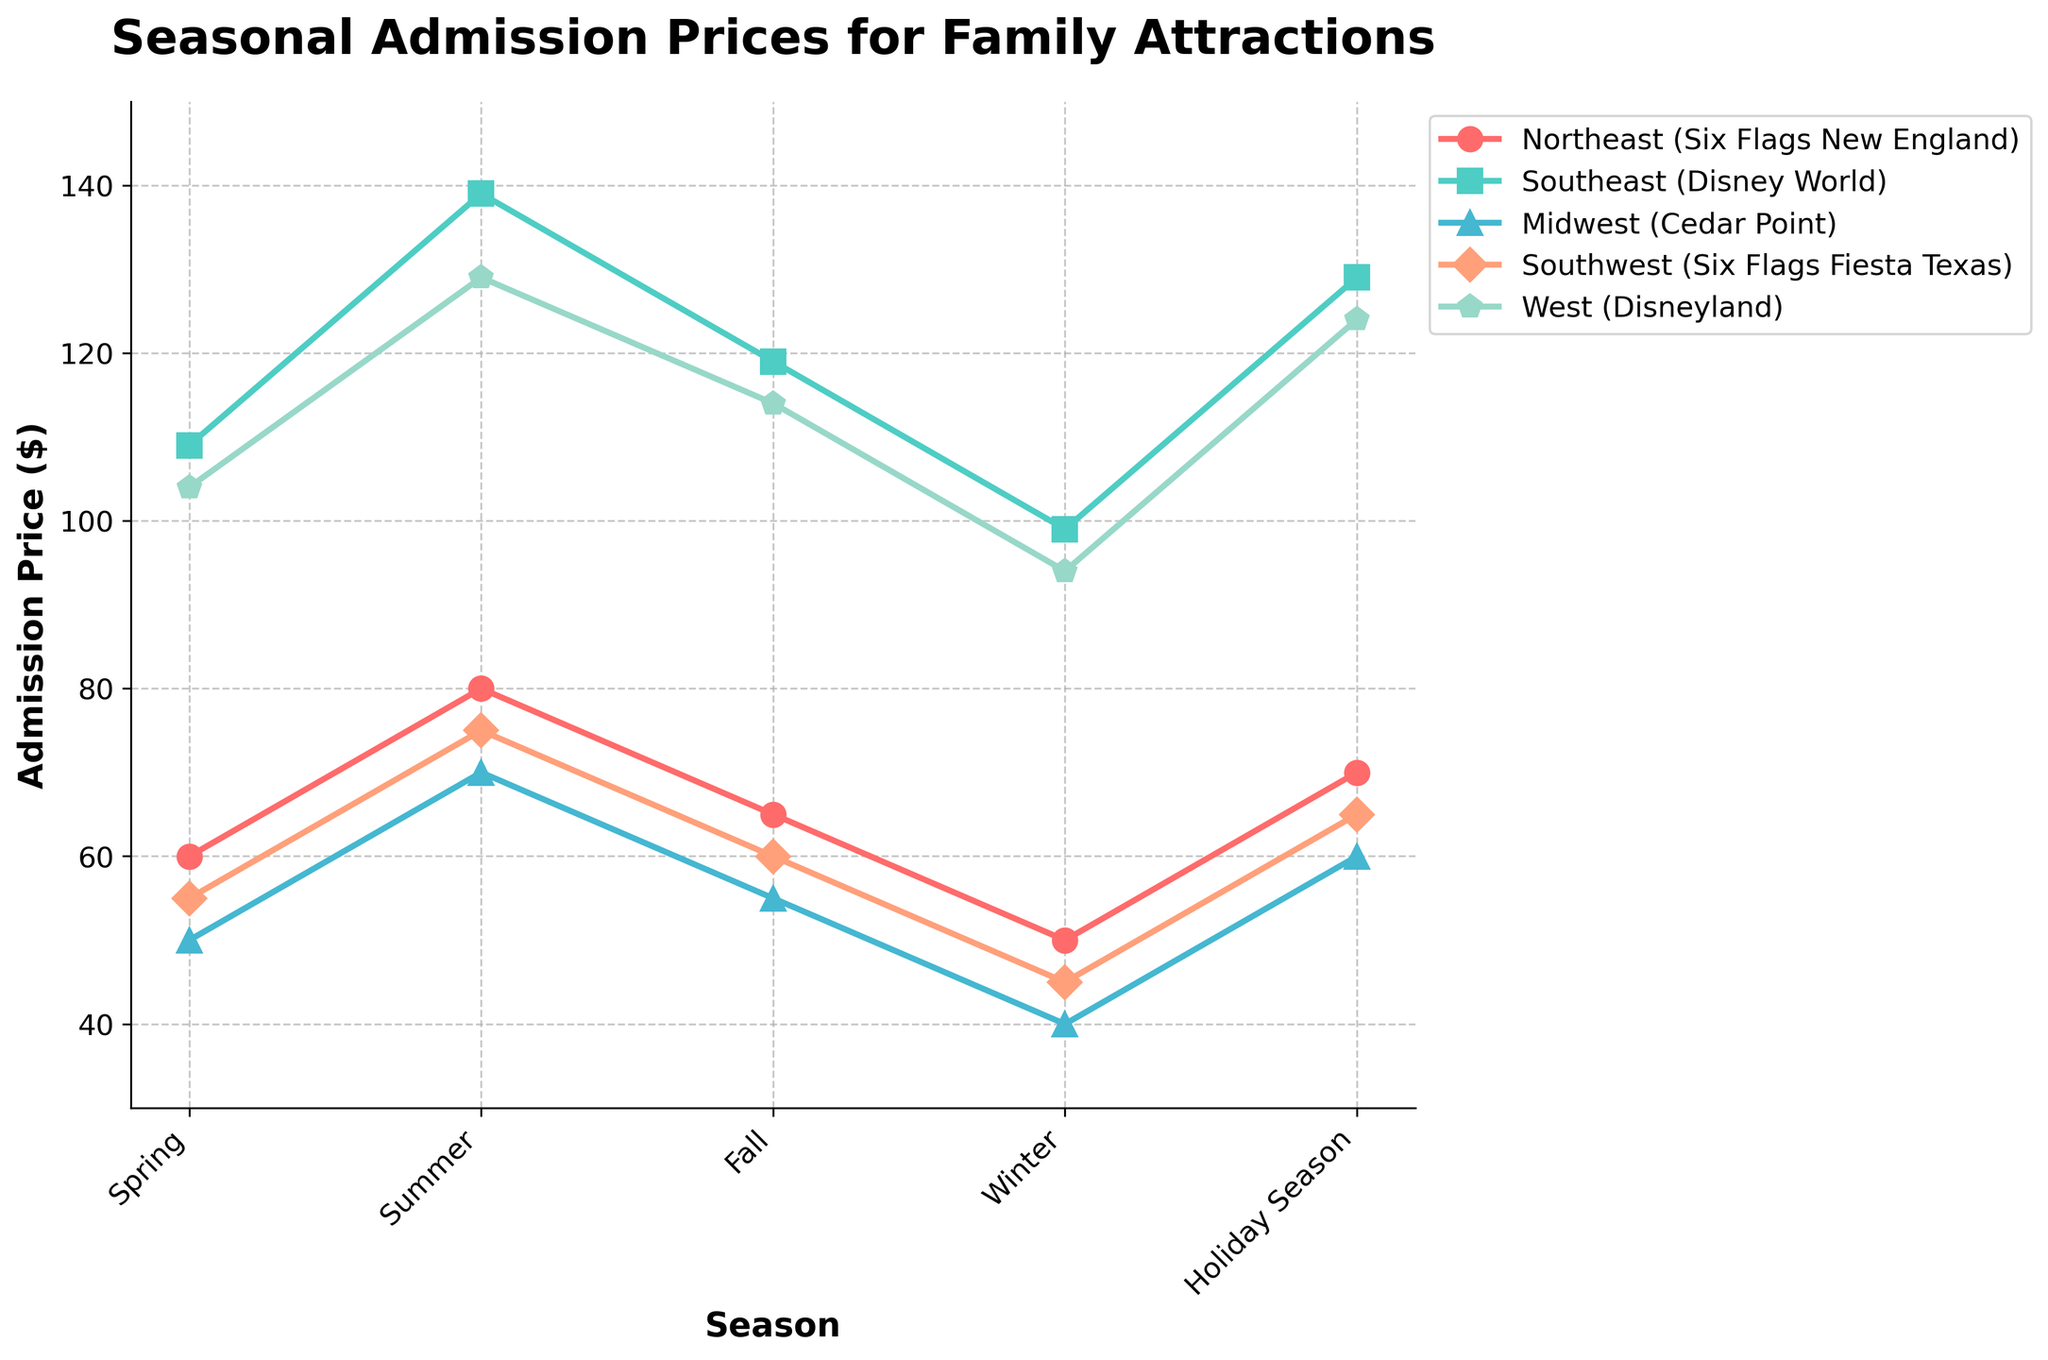what is the total admission price for Disneyland in each season? To find the total admission price for Disneyland across the five seasons, add the prices together: 104.00 (Spring) + 129.00 (Summer) + 114.00 (Fall) + 94.00 (Winter) + 124.00 (Holiday Season). This gives us a total of 565.00.
Answer: 565.00 Which attraction has the highest admission price in the summer? To determine the attraction with the highest admission price in the summer, compare the values for each attraction in the summer season: Six Flags New England (79.99), Disney World (139.00), Cedar Point (69.99), Six Flags Fiesta Texas (74.99), and Disneyland (129.00). Disney World has the highest admission price.
Answer: Disney World Which season shows the lowest admission price for Six Flags Fiesta Texas? To find the season with the lowest admission price for Six Flags Fiesta Texas, compare the prices across the seasons: Spring (54.99), Summer (74.99), Fall (59.99), Winter (44.99), and Holiday Season (64.99). The lowest price is in Winter at 44.99.
Answer: Winter Are there any attractions that have the same admission price across two different seasons? To see if any attractions have the same price in two seasons, compare each season's price for each attraction: Six Flags New England, Disney World, Cedar Point, Six Flags Fiesta Texas, and Disneyland. No attractions have repeated prices across two seasons.
Answer: No Between Spring and Fall, which region shows a greater change in admission prices for Cedar Point? Calculate the price difference for Cedar Point between Spring and Fall: Spring (49.99) - Fall (54.99) gives a change of -5 (an increase from Spring to Fall), the change's magnitude is 5.00.
Answer: 5.00 In the Holiday Season, which two attractions have the closest admission prices? Compare the admission prices for all attractions in the Holiday Season: Six Flags New England (69.99), Disney World (129.00), Cedar Point (59.99), Six Flags Fiesta Texas (64.99), and Disneyland (124.00). The closest prices are Cedar Point (59.99) and Six Flags Fiesta Texas (64.99) with a difference of 5.00.
Answer: Cedar Point & Six Flags Fiesta Texas 